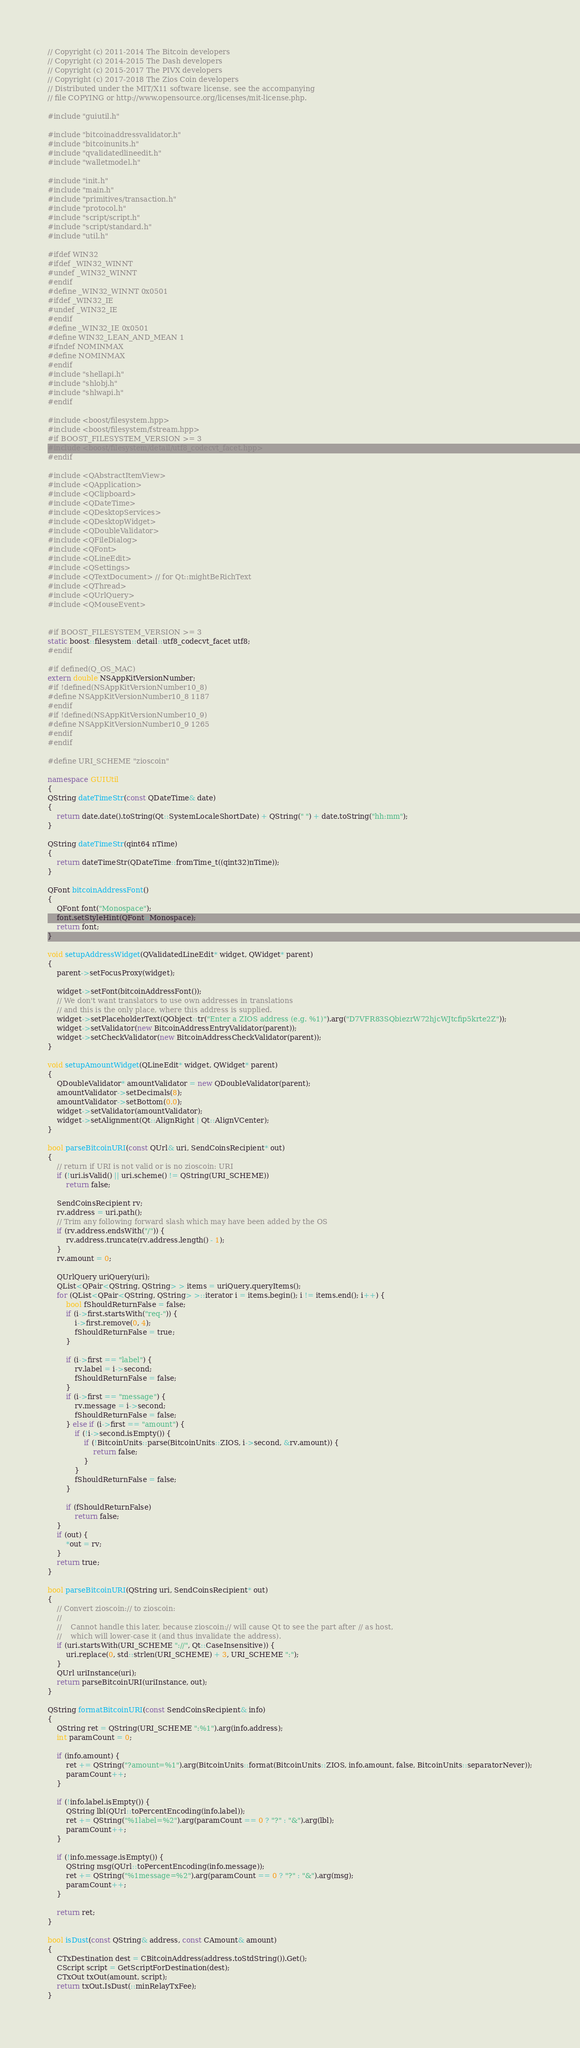Convert code to text. <code><loc_0><loc_0><loc_500><loc_500><_C++_>// Copyright (c) 2011-2014 The Bitcoin developers
// Copyright (c) 2014-2015 The Dash developers
// Copyright (c) 2015-2017 The PIVX developers
// Copyright (c) 2017-2018 The Zios Coin developers
// Distributed under the MIT/X11 software license, see the accompanying
// file COPYING or http://www.opensource.org/licenses/mit-license.php.

#include "guiutil.h"

#include "bitcoinaddressvalidator.h"
#include "bitcoinunits.h"
#include "qvalidatedlineedit.h"
#include "walletmodel.h"

#include "init.h"
#include "main.h"
#include "primitives/transaction.h"
#include "protocol.h"
#include "script/script.h"
#include "script/standard.h"
#include "util.h"

#ifdef WIN32
#ifdef _WIN32_WINNT
#undef _WIN32_WINNT
#endif
#define _WIN32_WINNT 0x0501
#ifdef _WIN32_IE
#undef _WIN32_IE
#endif
#define _WIN32_IE 0x0501
#define WIN32_LEAN_AND_MEAN 1
#ifndef NOMINMAX
#define NOMINMAX
#endif
#include "shellapi.h"
#include "shlobj.h"
#include "shlwapi.h"
#endif

#include <boost/filesystem.hpp>
#include <boost/filesystem/fstream.hpp>
#if BOOST_FILESYSTEM_VERSION >= 3
#include <boost/filesystem/detail/utf8_codecvt_facet.hpp>
#endif

#include <QAbstractItemView>
#include <QApplication>
#include <QClipboard>
#include <QDateTime>
#include <QDesktopServices>
#include <QDesktopWidget>
#include <QDoubleValidator>
#include <QFileDialog>
#include <QFont>
#include <QLineEdit>
#include <QSettings>
#include <QTextDocument> // for Qt::mightBeRichText
#include <QThread>
#include <QUrlQuery>
#include <QMouseEvent>


#if BOOST_FILESYSTEM_VERSION >= 3
static boost::filesystem::detail::utf8_codecvt_facet utf8;
#endif

#if defined(Q_OS_MAC)
extern double NSAppKitVersionNumber;
#if !defined(NSAppKitVersionNumber10_8)
#define NSAppKitVersionNumber10_8 1187
#endif
#if !defined(NSAppKitVersionNumber10_9)
#define NSAppKitVersionNumber10_9 1265
#endif
#endif

#define URI_SCHEME "zioscoin"

namespace GUIUtil
{
QString dateTimeStr(const QDateTime& date)
{
    return date.date().toString(Qt::SystemLocaleShortDate) + QString(" ") + date.toString("hh:mm");
}

QString dateTimeStr(qint64 nTime)
{
    return dateTimeStr(QDateTime::fromTime_t((qint32)nTime));
}

QFont bitcoinAddressFont()
{
    QFont font("Monospace");
    font.setStyleHint(QFont::Monospace);
    return font;
}

void setupAddressWidget(QValidatedLineEdit* widget, QWidget* parent)
{
    parent->setFocusProxy(widget);

    widget->setFont(bitcoinAddressFont());
    // We don't want translators to use own addresses in translations
    // and this is the only place, where this address is supplied.
    widget->setPlaceholderText(QObject::tr("Enter a ZIOS address (e.g. %1)").arg("D7VFR83SQbiezrW72hjcWJtcfip5krte2Z"));
    widget->setValidator(new BitcoinAddressEntryValidator(parent));
    widget->setCheckValidator(new BitcoinAddressCheckValidator(parent));
}

void setupAmountWidget(QLineEdit* widget, QWidget* parent)
{
    QDoubleValidator* amountValidator = new QDoubleValidator(parent);
    amountValidator->setDecimals(8);
    amountValidator->setBottom(0.0);
    widget->setValidator(amountValidator);
    widget->setAlignment(Qt::AlignRight | Qt::AlignVCenter);
}

bool parseBitcoinURI(const QUrl& uri, SendCoinsRecipient* out)
{
    // return if URI is not valid or is no zioscoin: URI
    if (!uri.isValid() || uri.scheme() != QString(URI_SCHEME))
        return false;

    SendCoinsRecipient rv;
    rv.address = uri.path();
    // Trim any following forward slash which may have been added by the OS
    if (rv.address.endsWith("/")) {
        rv.address.truncate(rv.address.length() - 1);
    }
    rv.amount = 0;

    QUrlQuery uriQuery(uri);
    QList<QPair<QString, QString> > items = uriQuery.queryItems();
    for (QList<QPair<QString, QString> >::iterator i = items.begin(); i != items.end(); i++) {
        bool fShouldReturnFalse = false;
        if (i->first.startsWith("req-")) {
            i->first.remove(0, 4);
            fShouldReturnFalse = true;
        }

        if (i->first == "label") {
            rv.label = i->second;
            fShouldReturnFalse = false;
        }
        if (i->first == "message") {
            rv.message = i->second;
            fShouldReturnFalse = false;
        } else if (i->first == "amount") {
            if (!i->second.isEmpty()) {
                if (!BitcoinUnits::parse(BitcoinUnits::ZIOS, i->second, &rv.amount)) {
                    return false;
                }
            }
            fShouldReturnFalse = false;
        }

        if (fShouldReturnFalse)
            return false;
    }
    if (out) {
        *out = rv;
    }
    return true;
}

bool parseBitcoinURI(QString uri, SendCoinsRecipient* out)
{
    // Convert zioscoin:// to zioscoin:
    //
    //    Cannot handle this later, because zioscoin:// will cause Qt to see the part after // as host,
    //    which will lower-case it (and thus invalidate the address).
    if (uri.startsWith(URI_SCHEME "://", Qt::CaseInsensitive)) {
        uri.replace(0, std::strlen(URI_SCHEME) + 3, URI_SCHEME ":");
    }
    QUrl uriInstance(uri);
    return parseBitcoinURI(uriInstance, out);
}

QString formatBitcoinURI(const SendCoinsRecipient& info)
{
    QString ret = QString(URI_SCHEME ":%1").arg(info.address);
    int paramCount = 0;

    if (info.amount) {
        ret += QString("?amount=%1").arg(BitcoinUnits::format(BitcoinUnits::ZIOS, info.amount, false, BitcoinUnits::separatorNever));
        paramCount++;
    }

    if (!info.label.isEmpty()) {
        QString lbl(QUrl::toPercentEncoding(info.label));
        ret += QString("%1label=%2").arg(paramCount == 0 ? "?" : "&").arg(lbl);
        paramCount++;
    }

    if (!info.message.isEmpty()) {
        QString msg(QUrl::toPercentEncoding(info.message));
        ret += QString("%1message=%2").arg(paramCount == 0 ? "?" : "&").arg(msg);
        paramCount++;
    }

    return ret;
}

bool isDust(const QString& address, const CAmount& amount)
{
    CTxDestination dest = CBitcoinAddress(address.toStdString()).Get();
    CScript script = GetScriptForDestination(dest);
    CTxOut txOut(amount, script);
    return txOut.IsDust(::minRelayTxFee);
}
</code> 